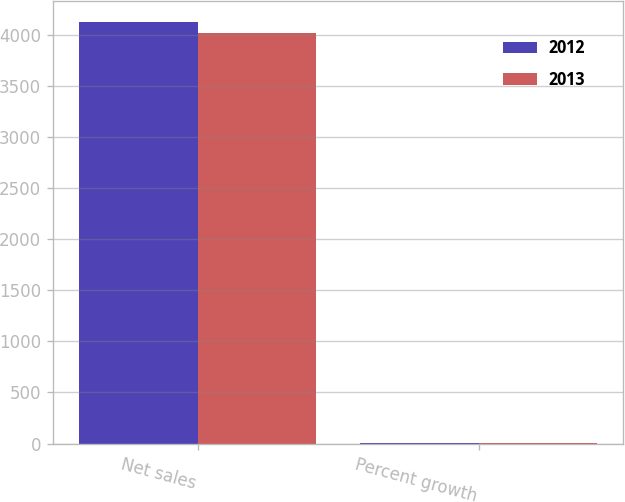<chart> <loc_0><loc_0><loc_500><loc_500><stacked_bar_chart><ecel><fcel>Net sales<fcel>Percent growth<nl><fcel>2012<fcel>4123.4<fcel>2.7<nl><fcel>2013<fcel>4014.2<fcel>8.6<nl></chart> 